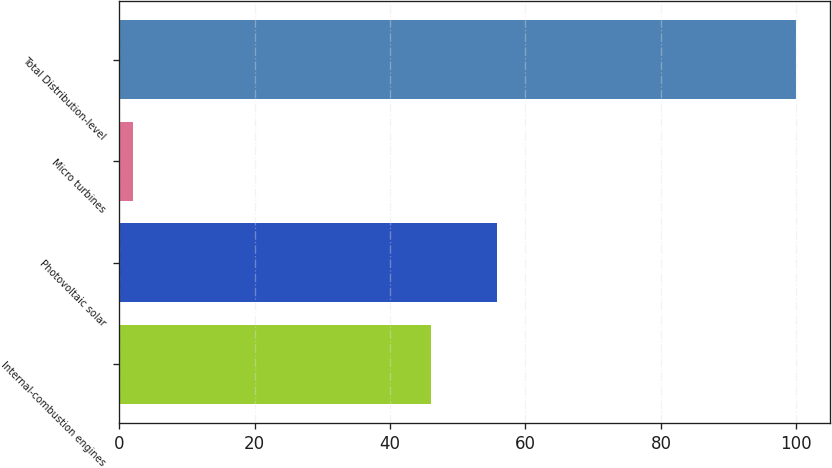<chart> <loc_0><loc_0><loc_500><loc_500><bar_chart><fcel>Internal-combustion engines<fcel>Photovoltaic solar<fcel>Micro turbines<fcel>Total Distribution-level<nl><fcel>46<fcel>55.8<fcel>2<fcel>100<nl></chart> 